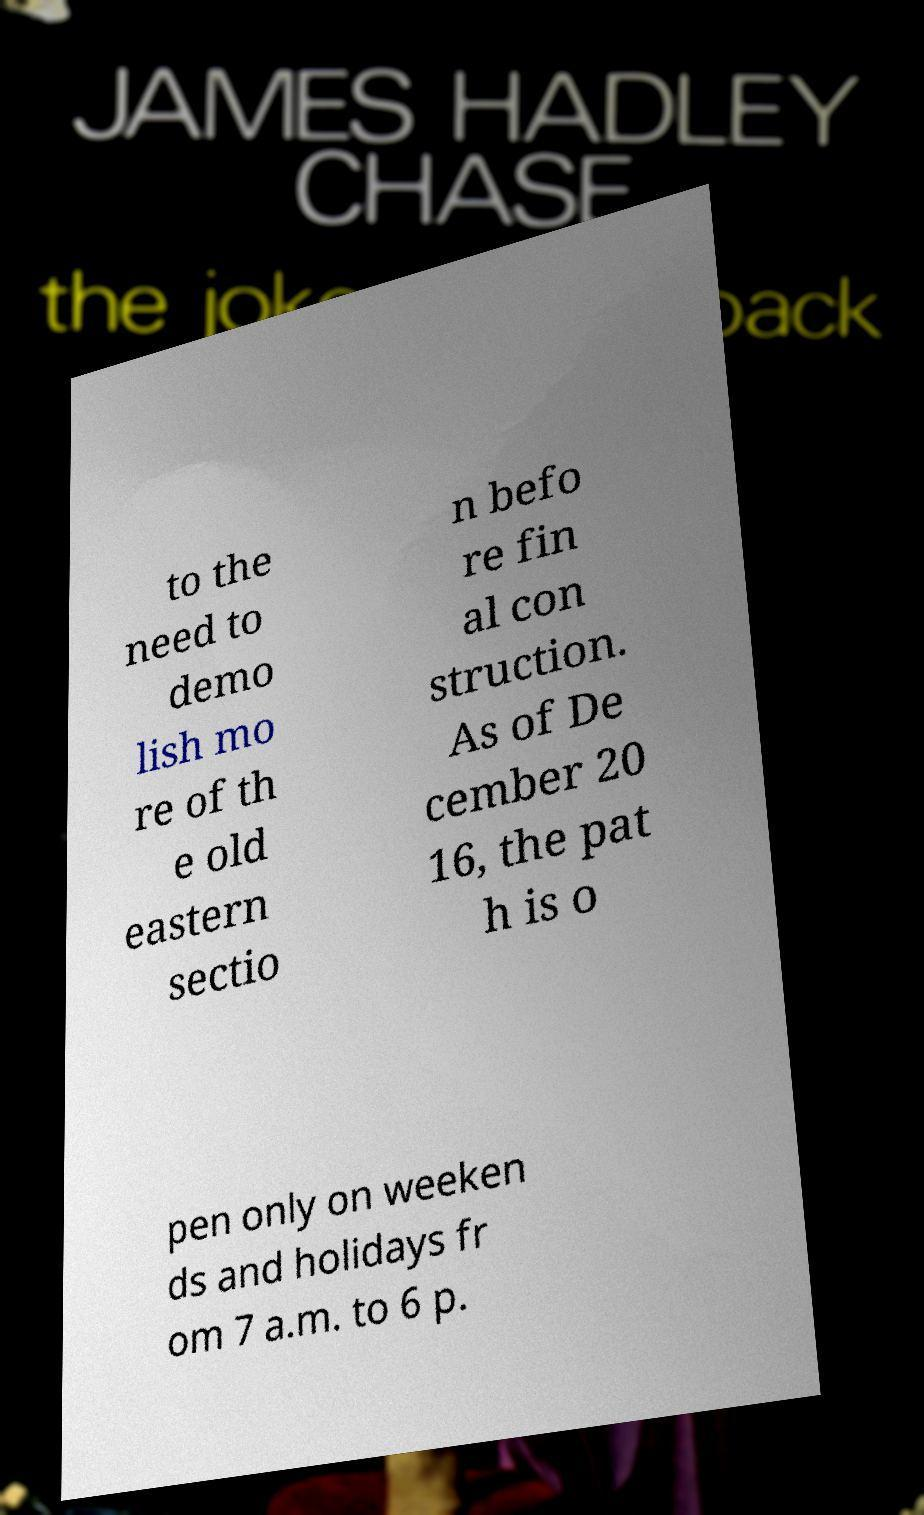I need the written content from this picture converted into text. Can you do that? to the need to demo lish mo re of th e old eastern sectio n befo re fin al con struction. As of De cember 20 16, the pat h is o pen only on weeken ds and holidays fr om 7 a.m. to 6 p. 